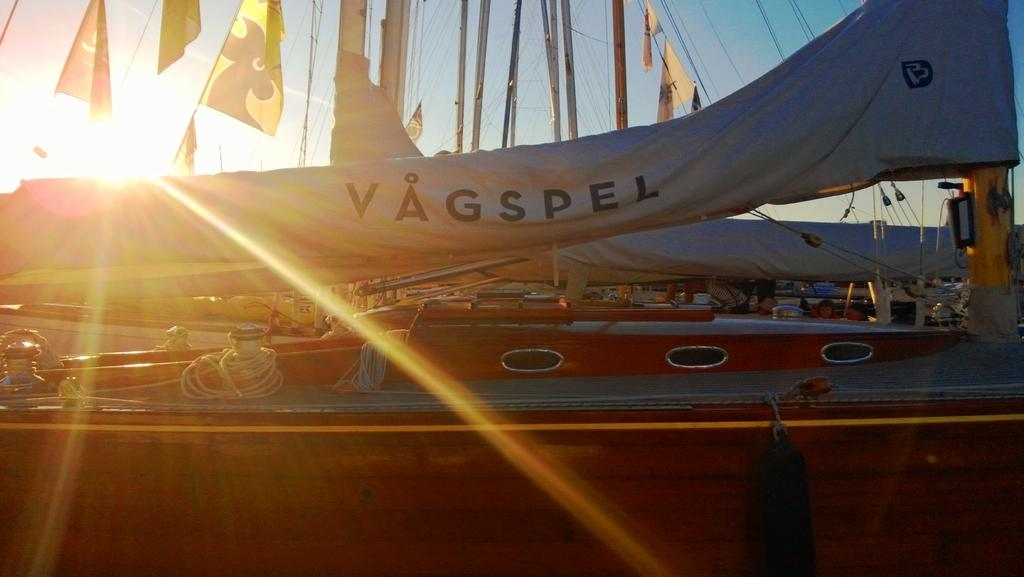<image>
Write a terse but informative summary of the picture. Parked and covered airplane named Vagspel on a sunny day. 